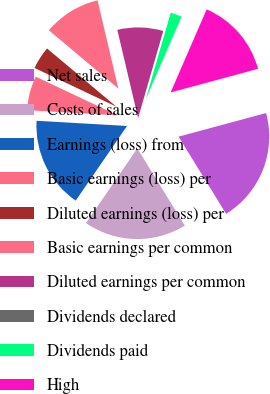<chart> <loc_0><loc_0><loc_500><loc_500><pie_chart><fcel>Net sales<fcel>Costs of sales<fcel>Earnings (loss) from<fcel>Basic earnings (loss) per<fcel>Diluted earnings (loss) per<fcel>Basic earnings per common<fcel>Diluted earnings per common<fcel>Dividends declared<fcel>Dividends paid<fcel>High<nl><fcel>20.4%<fcel>18.36%<fcel>16.32%<fcel>6.12%<fcel>4.08%<fcel>10.2%<fcel>8.16%<fcel>0.0%<fcel>2.04%<fcel>14.28%<nl></chart> 